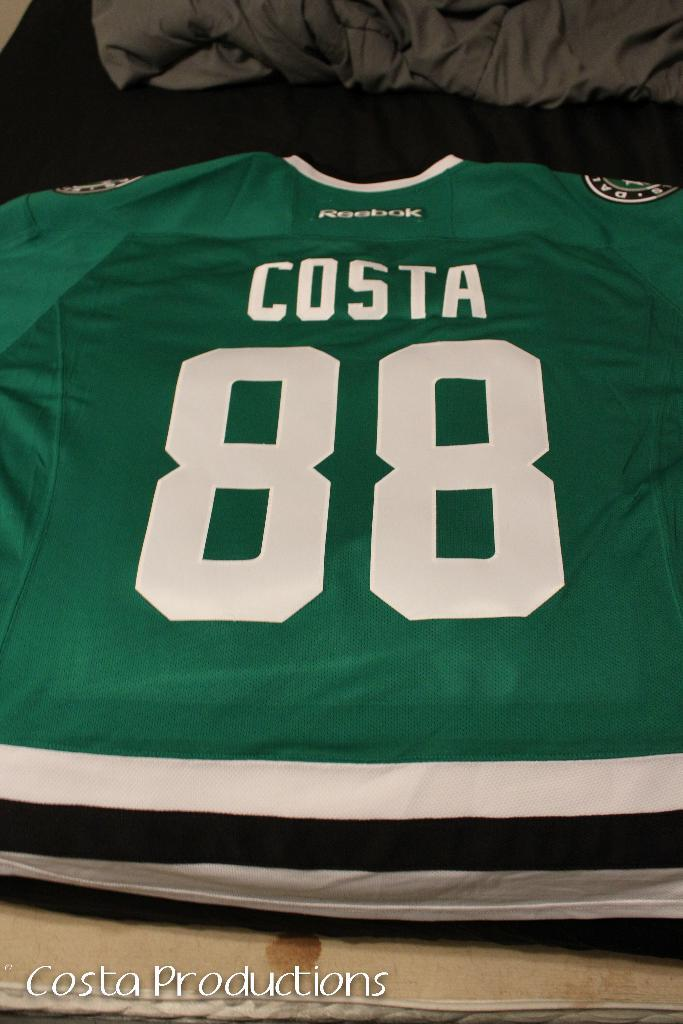<image>
Relay a brief, clear account of the picture shown. A jersey that says Costa and number 88 is green and white. 